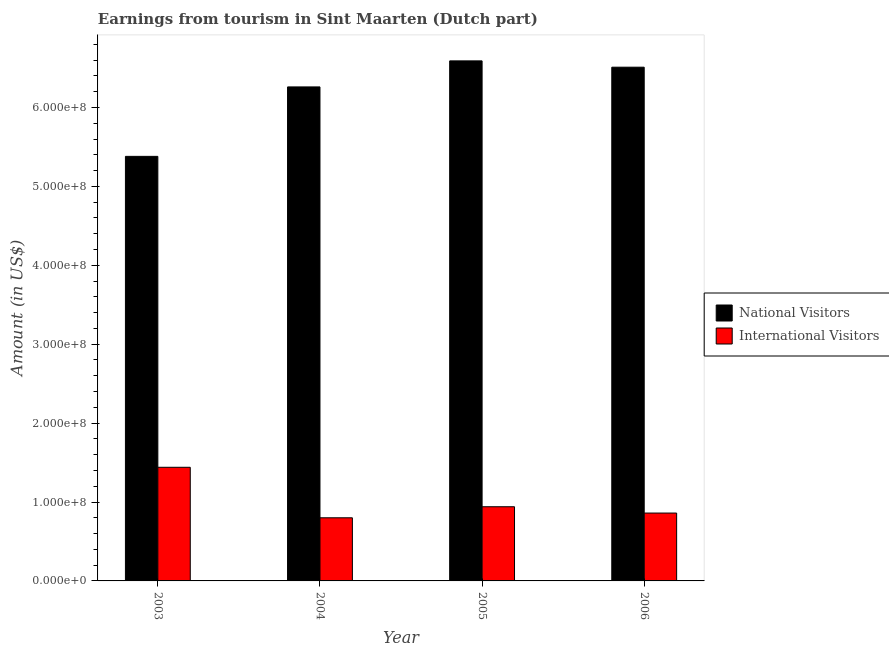How many groups of bars are there?
Keep it short and to the point. 4. Are the number of bars on each tick of the X-axis equal?
Keep it short and to the point. Yes. How many bars are there on the 1st tick from the right?
Your response must be concise. 2. What is the label of the 3rd group of bars from the left?
Your answer should be compact. 2005. In how many cases, is the number of bars for a given year not equal to the number of legend labels?
Make the answer very short. 0. What is the amount earned from international visitors in 2004?
Your answer should be very brief. 8.00e+07. Across all years, what is the maximum amount earned from international visitors?
Make the answer very short. 1.44e+08. Across all years, what is the minimum amount earned from international visitors?
Your answer should be very brief. 8.00e+07. In which year was the amount earned from international visitors minimum?
Provide a short and direct response. 2004. What is the total amount earned from national visitors in the graph?
Keep it short and to the point. 2.47e+09. What is the difference between the amount earned from national visitors in 2004 and that in 2006?
Your answer should be very brief. -2.50e+07. What is the difference between the amount earned from national visitors in 2005 and the amount earned from international visitors in 2004?
Your response must be concise. 3.30e+07. What is the average amount earned from international visitors per year?
Your answer should be very brief. 1.01e+08. In how many years, is the amount earned from international visitors greater than 360000000 US$?
Keep it short and to the point. 0. What is the ratio of the amount earned from national visitors in 2003 to that in 2005?
Give a very brief answer. 0.82. Is the amount earned from international visitors in 2003 less than that in 2006?
Your response must be concise. No. What is the difference between the highest and the lowest amount earned from international visitors?
Your response must be concise. 6.40e+07. What does the 1st bar from the left in 2006 represents?
Your answer should be very brief. National Visitors. What does the 2nd bar from the right in 2006 represents?
Ensure brevity in your answer.  National Visitors. Are all the bars in the graph horizontal?
Your answer should be very brief. No. Does the graph contain grids?
Ensure brevity in your answer.  No. Where does the legend appear in the graph?
Offer a terse response. Center right. How many legend labels are there?
Provide a succinct answer. 2. How are the legend labels stacked?
Keep it short and to the point. Vertical. What is the title of the graph?
Offer a very short reply. Earnings from tourism in Sint Maarten (Dutch part). What is the Amount (in US$) in National Visitors in 2003?
Your response must be concise. 5.38e+08. What is the Amount (in US$) of International Visitors in 2003?
Provide a succinct answer. 1.44e+08. What is the Amount (in US$) of National Visitors in 2004?
Provide a short and direct response. 6.26e+08. What is the Amount (in US$) of International Visitors in 2004?
Your response must be concise. 8.00e+07. What is the Amount (in US$) of National Visitors in 2005?
Keep it short and to the point. 6.59e+08. What is the Amount (in US$) in International Visitors in 2005?
Your answer should be very brief. 9.40e+07. What is the Amount (in US$) of National Visitors in 2006?
Give a very brief answer. 6.51e+08. What is the Amount (in US$) in International Visitors in 2006?
Keep it short and to the point. 8.60e+07. Across all years, what is the maximum Amount (in US$) in National Visitors?
Keep it short and to the point. 6.59e+08. Across all years, what is the maximum Amount (in US$) of International Visitors?
Your answer should be very brief. 1.44e+08. Across all years, what is the minimum Amount (in US$) of National Visitors?
Your answer should be compact. 5.38e+08. Across all years, what is the minimum Amount (in US$) in International Visitors?
Offer a very short reply. 8.00e+07. What is the total Amount (in US$) in National Visitors in the graph?
Offer a very short reply. 2.47e+09. What is the total Amount (in US$) in International Visitors in the graph?
Provide a short and direct response. 4.04e+08. What is the difference between the Amount (in US$) in National Visitors in 2003 and that in 2004?
Make the answer very short. -8.80e+07. What is the difference between the Amount (in US$) of International Visitors in 2003 and that in 2004?
Your answer should be compact. 6.40e+07. What is the difference between the Amount (in US$) in National Visitors in 2003 and that in 2005?
Provide a short and direct response. -1.21e+08. What is the difference between the Amount (in US$) in International Visitors in 2003 and that in 2005?
Your response must be concise. 5.00e+07. What is the difference between the Amount (in US$) of National Visitors in 2003 and that in 2006?
Ensure brevity in your answer.  -1.13e+08. What is the difference between the Amount (in US$) in International Visitors in 2003 and that in 2006?
Give a very brief answer. 5.80e+07. What is the difference between the Amount (in US$) in National Visitors in 2004 and that in 2005?
Provide a succinct answer. -3.30e+07. What is the difference between the Amount (in US$) of International Visitors in 2004 and that in 2005?
Ensure brevity in your answer.  -1.40e+07. What is the difference between the Amount (in US$) in National Visitors in 2004 and that in 2006?
Ensure brevity in your answer.  -2.50e+07. What is the difference between the Amount (in US$) of International Visitors in 2004 and that in 2006?
Provide a short and direct response. -6.00e+06. What is the difference between the Amount (in US$) in National Visitors in 2003 and the Amount (in US$) in International Visitors in 2004?
Give a very brief answer. 4.58e+08. What is the difference between the Amount (in US$) in National Visitors in 2003 and the Amount (in US$) in International Visitors in 2005?
Offer a very short reply. 4.44e+08. What is the difference between the Amount (in US$) in National Visitors in 2003 and the Amount (in US$) in International Visitors in 2006?
Your answer should be compact. 4.52e+08. What is the difference between the Amount (in US$) in National Visitors in 2004 and the Amount (in US$) in International Visitors in 2005?
Provide a succinct answer. 5.32e+08. What is the difference between the Amount (in US$) of National Visitors in 2004 and the Amount (in US$) of International Visitors in 2006?
Keep it short and to the point. 5.40e+08. What is the difference between the Amount (in US$) in National Visitors in 2005 and the Amount (in US$) in International Visitors in 2006?
Make the answer very short. 5.73e+08. What is the average Amount (in US$) in National Visitors per year?
Give a very brief answer. 6.18e+08. What is the average Amount (in US$) of International Visitors per year?
Offer a terse response. 1.01e+08. In the year 2003, what is the difference between the Amount (in US$) in National Visitors and Amount (in US$) in International Visitors?
Your answer should be compact. 3.94e+08. In the year 2004, what is the difference between the Amount (in US$) in National Visitors and Amount (in US$) in International Visitors?
Ensure brevity in your answer.  5.46e+08. In the year 2005, what is the difference between the Amount (in US$) in National Visitors and Amount (in US$) in International Visitors?
Give a very brief answer. 5.65e+08. In the year 2006, what is the difference between the Amount (in US$) of National Visitors and Amount (in US$) of International Visitors?
Keep it short and to the point. 5.65e+08. What is the ratio of the Amount (in US$) of National Visitors in 2003 to that in 2004?
Make the answer very short. 0.86. What is the ratio of the Amount (in US$) in International Visitors in 2003 to that in 2004?
Keep it short and to the point. 1.8. What is the ratio of the Amount (in US$) of National Visitors in 2003 to that in 2005?
Make the answer very short. 0.82. What is the ratio of the Amount (in US$) of International Visitors in 2003 to that in 2005?
Your answer should be very brief. 1.53. What is the ratio of the Amount (in US$) of National Visitors in 2003 to that in 2006?
Offer a very short reply. 0.83. What is the ratio of the Amount (in US$) in International Visitors in 2003 to that in 2006?
Ensure brevity in your answer.  1.67. What is the ratio of the Amount (in US$) of National Visitors in 2004 to that in 2005?
Keep it short and to the point. 0.95. What is the ratio of the Amount (in US$) in International Visitors in 2004 to that in 2005?
Provide a short and direct response. 0.85. What is the ratio of the Amount (in US$) of National Visitors in 2004 to that in 2006?
Make the answer very short. 0.96. What is the ratio of the Amount (in US$) in International Visitors in 2004 to that in 2006?
Give a very brief answer. 0.93. What is the ratio of the Amount (in US$) in National Visitors in 2005 to that in 2006?
Offer a very short reply. 1.01. What is the ratio of the Amount (in US$) of International Visitors in 2005 to that in 2006?
Offer a very short reply. 1.09. What is the difference between the highest and the lowest Amount (in US$) in National Visitors?
Make the answer very short. 1.21e+08. What is the difference between the highest and the lowest Amount (in US$) of International Visitors?
Keep it short and to the point. 6.40e+07. 